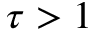Convert formula to latex. <formula><loc_0><loc_0><loc_500><loc_500>\tau > 1</formula> 